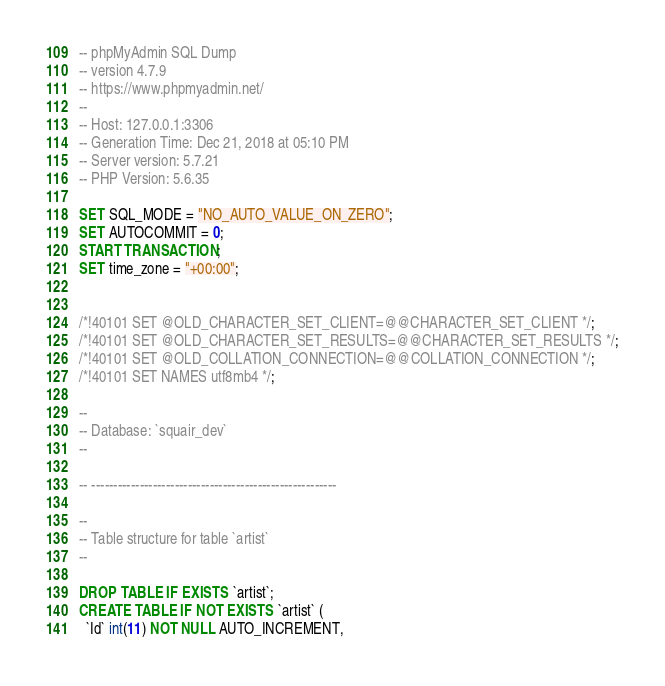<code> <loc_0><loc_0><loc_500><loc_500><_SQL_>-- phpMyAdmin SQL Dump
-- version 4.7.9
-- https://www.phpmyadmin.net/
--
-- Host: 127.0.0.1:3306
-- Generation Time: Dec 21, 2018 at 05:10 PM
-- Server version: 5.7.21
-- PHP Version: 5.6.35

SET SQL_MODE = "NO_AUTO_VALUE_ON_ZERO";
SET AUTOCOMMIT = 0;
START TRANSACTION;
SET time_zone = "+00:00";


/*!40101 SET @OLD_CHARACTER_SET_CLIENT=@@CHARACTER_SET_CLIENT */;
/*!40101 SET @OLD_CHARACTER_SET_RESULTS=@@CHARACTER_SET_RESULTS */;
/*!40101 SET @OLD_COLLATION_CONNECTION=@@COLLATION_CONNECTION */;
/*!40101 SET NAMES utf8mb4 */;

--
-- Database: `squair_dev`
--

-- --------------------------------------------------------

--
-- Table structure for table `artist`
--

DROP TABLE IF EXISTS `artist`;
CREATE TABLE IF NOT EXISTS `artist` (
  `Id` int(11) NOT NULL AUTO_INCREMENT,</code> 